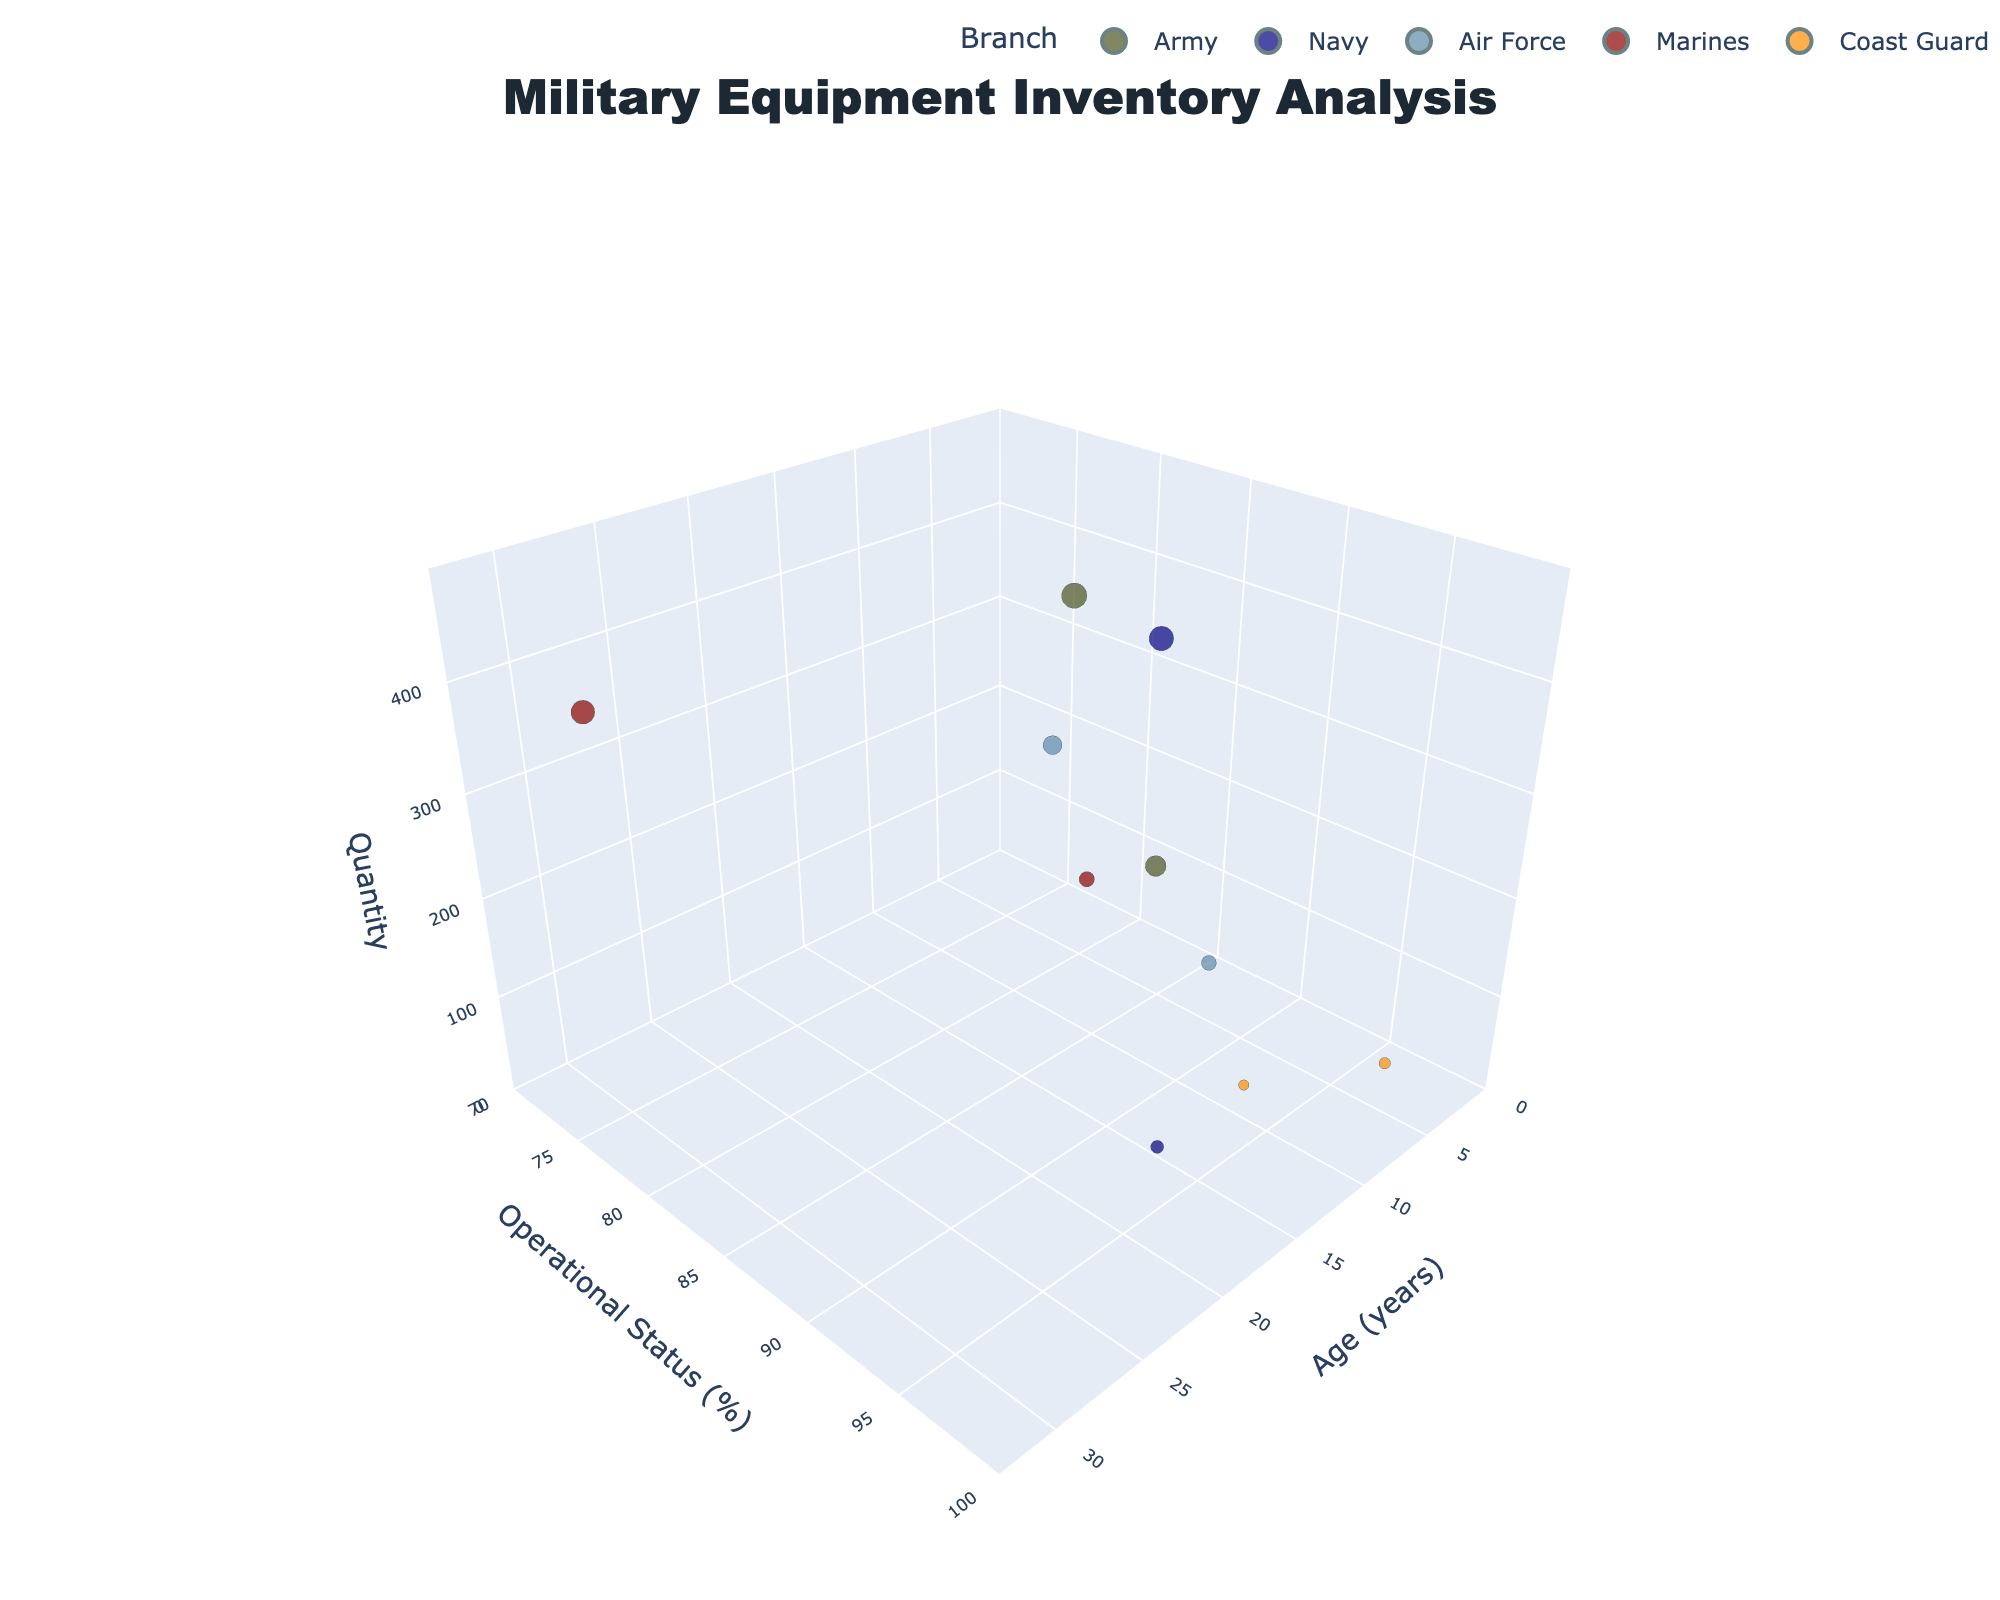What is the operational status of the Army's UH-60 Black Hawk? To find the operational status, look for the UH-60 Black Hawk data point on the figure. The y-axis represents operational status, and the UH-60 Black Hawk for the Army has a y-value at 92%.
Answer: 92% Which branch has the oldest equipment, and what is it? To determine the oldest equipment, examine the x-axis which represents the age. The oldest bubble lies furthest to the right (highest age value). This bubble corresponds to the Marines' AAV-7 Amphibious Assault Vehicle.
Answer: Marines, AAV-7 Amphibious Assault Vehicle How many pieces of equipment does the Air Force's F-35A Lightning II have? The z-axis represents the quantity, and by locating the bubble for the Air Force's F-35A Lightning II, you can see that it is near the 220 mark on the z-axis.
Answer: 220 Which branch has the highest operational status and what is the percentage? The highest operational status can be identified by looking at the highest point on the y-axis. The Coast Guard's Sentinel-class Cutter has an operational status of 97%.
Answer: Coast Guard, 97% Compare the quantities of Army’s M1A2 Abrams Tank and the Navy’s F/A-18 Super Hornet. Which one has a higher quantity and by how much? Look at the z-axis values for the M1A2 Abrams Tank (450) and the F/A-18 Super Hornet (420). Subtract the lower quantity from the higher quantity (450 - 420).
Answer: Army’s M1A2 Abrams Tank by 30 What is the youngest equipment in the Navy and its operational status? To find the youngest equipment, look for the smallest x-axis value within the Navy’s set of bubbles. The F/A-18 Super Hornet at 10 years is the youngest. Check its y-axis value for operational status, which is 88%.
Answer: F/A-18 Super Hornet, 88% Which equipment has a quantity of 110 and what is its operational status? Observe the z-axis to locate the data point corresponding to a quantity of 110. This aligns with the Air Force’s C-130J Super Hercules. The operational status is found on the y-axis, which is at 90%.
Answer: C-130J Super Hercules, 90% Which branch has more equipment with an operational status greater than 90%, and what are they? Identify bubbles with y-axis values greater than 90%. The Coast Guard has both the HC-144 Ocean Sentry (93%) and Sentinel-class Cutter (97%), making it the branch with the most equipment above 90%.
Answer: Coast Guard, HC-144 Ocean Sentry and Sentinel-class Cutter 